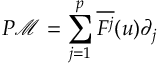Convert formula to latex. <formula><loc_0><loc_0><loc_500><loc_500>P \mathcal { M } = \sum _ { j = 1 } ^ { p } \overline { { F ^ { j } } } ( u ) \partial _ { j }</formula> 